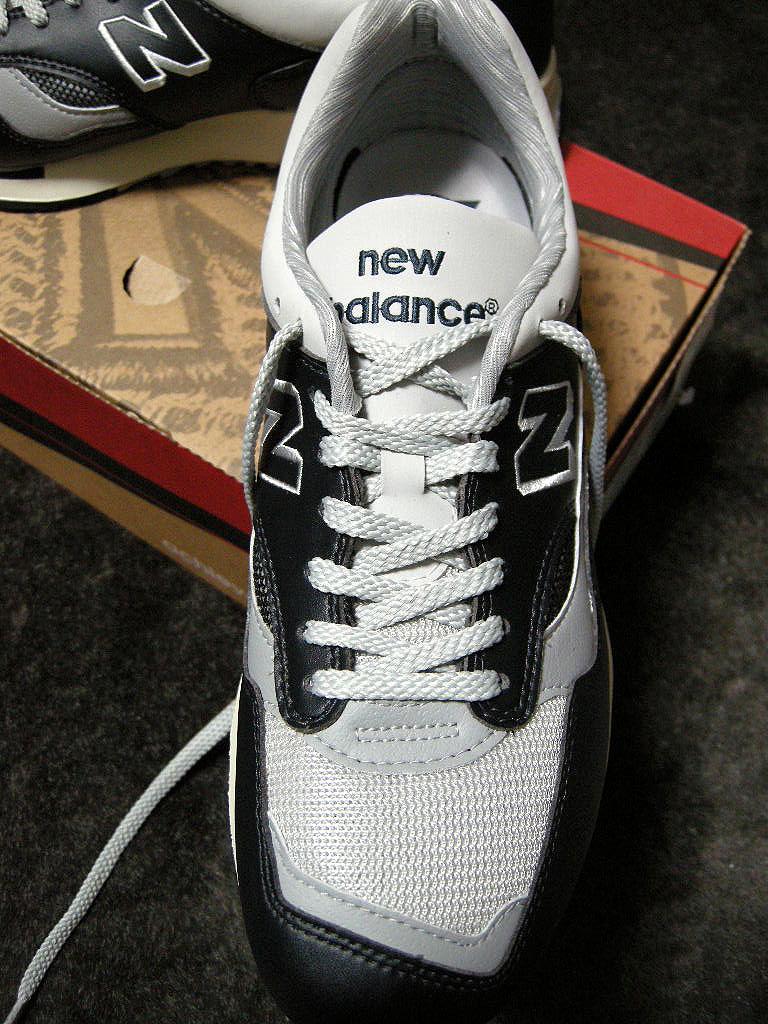How would you summarize this image in a sentence or two? In this image I can see the shoes on the cardboard box. The box is on the grey color surface. These shoes are in white and black color. 